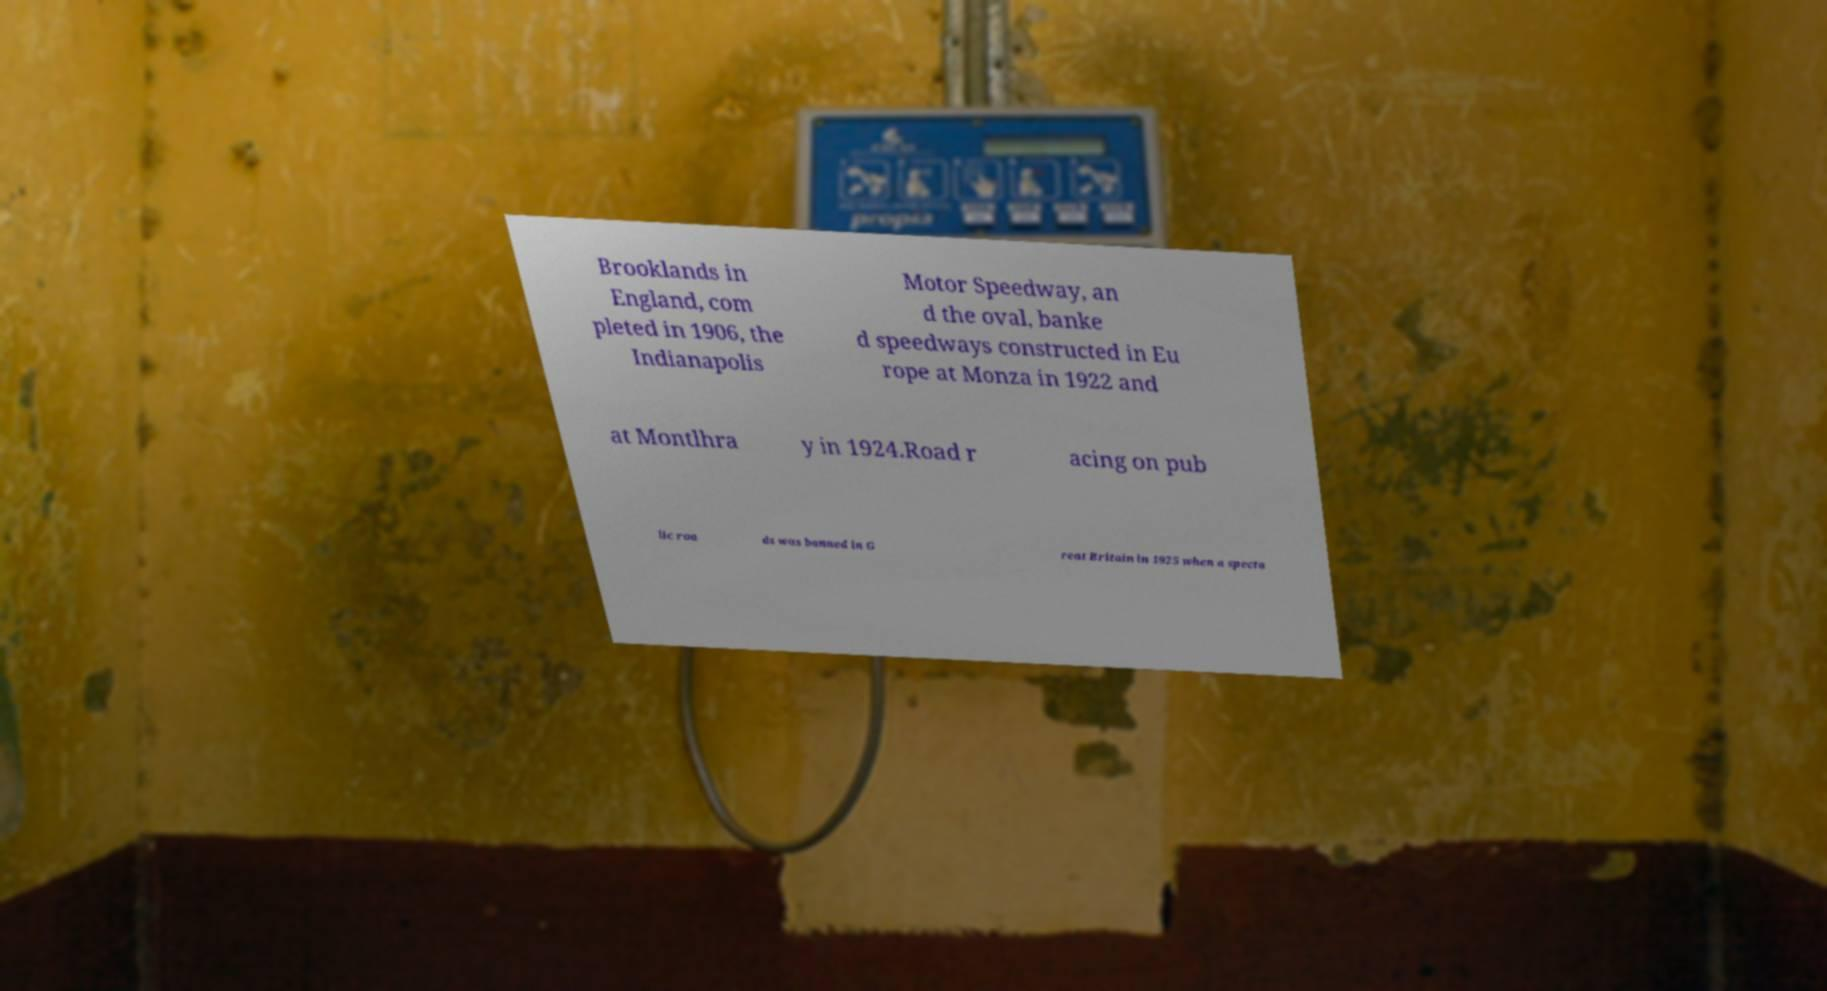Please read and relay the text visible in this image. What does it say? Brooklands in England, com pleted in 1906, the Indianapolis Motor Speedway, an d the oval, banke d speedways constructed in Eu rope at Monza in 1922 and at Montlhra y in 1924.Road r acing on pub lic roa ds was banned in G reat Britain in 1925 when a specta 